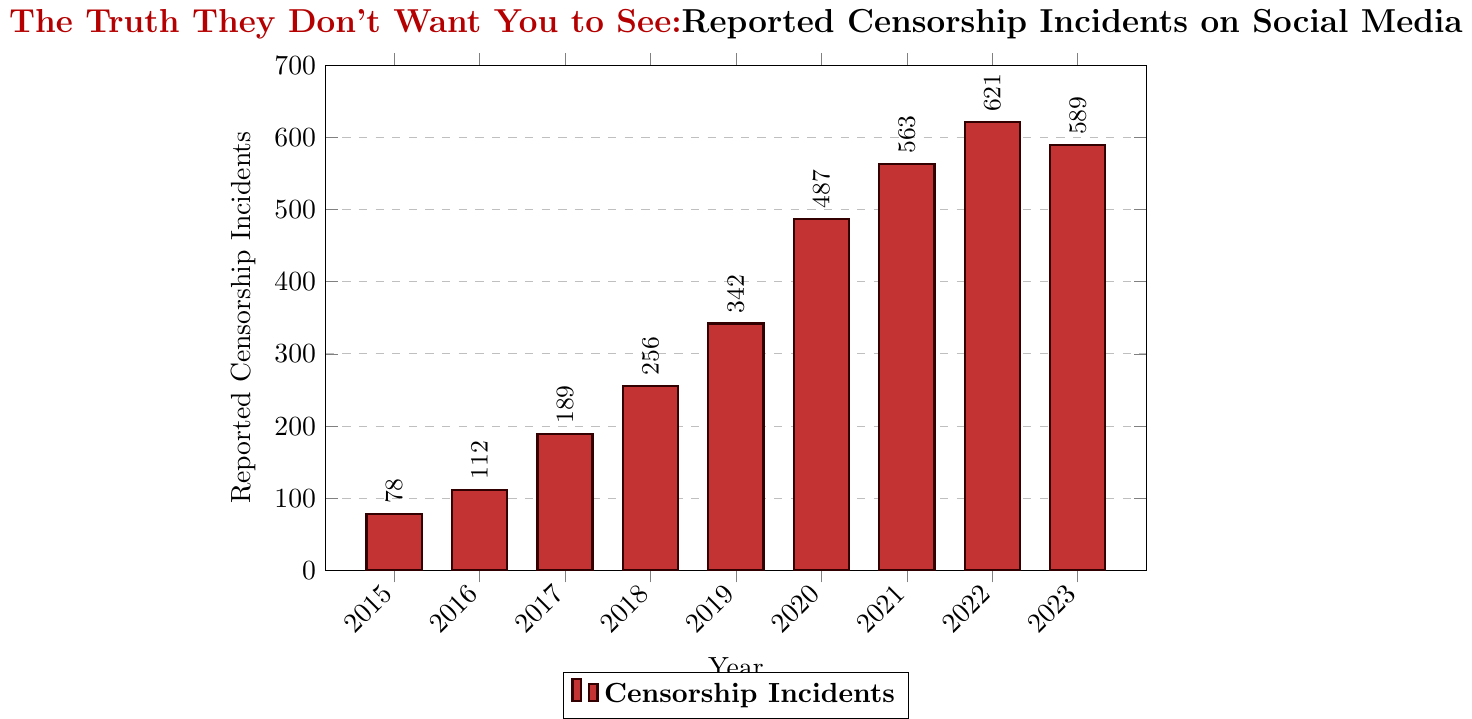What trend do you notice in reported censorship incidents from 2015 to 2022? From 2015 to 2022, there is a steady increase in reported censorship incidents each year, starting from 78 incidents in 2015 and reaching 621 in 2022.
Answer: Steady increase Which year had the highest number of reported censorship incidents? By examining the heights of the bars, the year 2022 has the highest bar, indicating the highest number of reported censorship incidents (621).
Answer: 2022 How many more incidents were reported in 2020 compared to 2015? Subtract the number of incidents in 2015 from the number in 2020: 487 - 78 = 409.
Answer: 409 What is the average number of reported censorship incidents from 2015 to 2023? Add the incidents from all years (78 + 112 + 189 + 256 + 342 + 487 + 563 + 621 + 589 = 3237), then divide by the number of years (9): 3237 / 9 ≈ 359.67.
Answer: Approximately 359.67 Which year had the lowest number of reported censorship incidents? By looking at the bars, the shortest bar corresponds to the year 2015 with 78 incidents.
Answer: 2015 Did the number of reported censorship incidents increase or decrease from 2022 to 2023? The bar for 2023 is slightly shorter than the bar for 2022, indicating a decrease from 621 to 589.
Answer: Decrease What is the total number of reported censorship incidents over the 9-year period? Sum the number of incidents from all years: 78 + 112 + 189 + 256 + 342 + 487 + 563 + 621 + 589 = 3237.
Answer: 3237 By how much did the number of incidents increase from 2018 to 2019? Subtract the number of incidents in 2018 from the number in 2019: 342 - 256 = 86.
Answer: 86 Which two consecutive years saw the largest increase in reported censorship incidents? Calculate the year-to-year differences and compare: 2016 - 2015 = 34, 2017 - 2016 = 77, 2018 - 2017 = 67, 2019 - 2018 = 86, 2020 - 2019 = 145, 2021 - 2020 = 76, 2022 - 2021 = 58, 2023 - 2022 = -32. The largest increase is from 2019 to 2020 (145).
Answer: 2019 to 2020 What was the total increase in reported censorship incidents from 2015 to 2023? Subtract the number in 2015 from the number in 2023: 589 - 78 = 511.
Answer: 511 